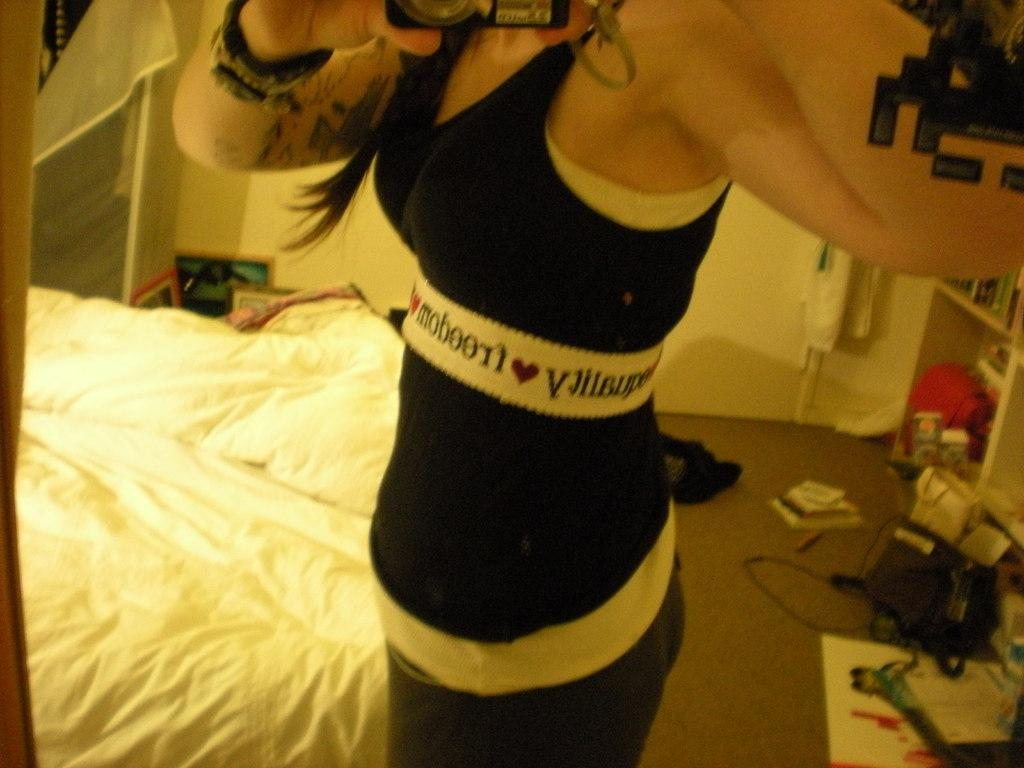What is the person in the image doing? The person is standing beside the bed and holding a camera. What might the person be planning to do with the camera? The person might be planning to take a picture of something or someone. What can be seen in the background of the image? There are many objects visible in the background. What type of corn can be seen growing in the image? There is no corn present in the image. 